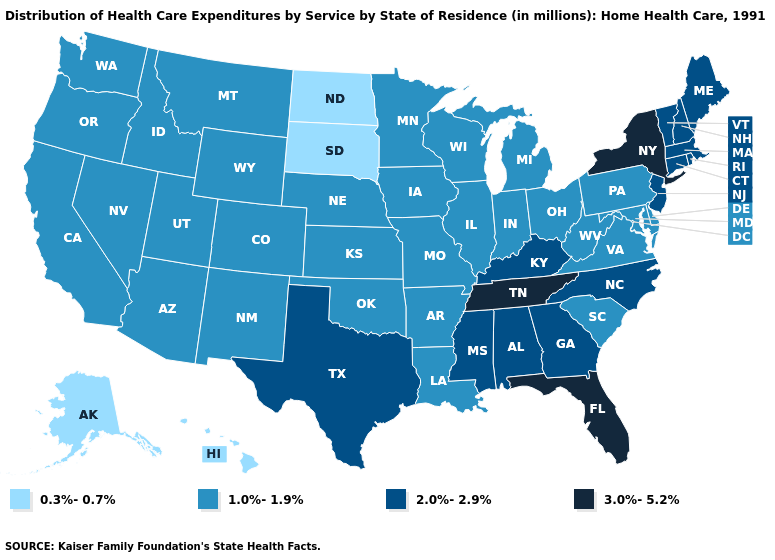What is the value of Michigan?
Answer briefly. 1.0%-1.9%. Name the states that have a value in the range 3.0%-5.2%?
Concise answer only. Florida, New York, Tennessee. Does Colorado have a lower value than North Carolina?
Write a very short answer. Yes. Does the map have missing data?
Quick response, please. No. Does Oregon have the lowest value in the USA?
Be succinct. No. What is the value of Arkansas?
Give a very brief answer. 1.0%-1.9%. What is the highest value in the USA?
Short answer required. 3.0%-5.2%. What is the value of Rhode Island?
Quick response, please. 2.0%-2.9%. Does Vermont have a lower value than North Carolina?
Concise answer only. No. What is the lowest value in states that border Kansas?
Keep it brief. 1.0%-1.9%. Does Nebraska have a lower value than Massachusetts?
Keep it brief. Yes. What is the value of Georgia?
Give a very brief answer. 2.0%-2.9%. What is the value of Wisconsin?
Concise answer only. 1.0%-1.9%. What is the value of Indiana?
Quick response, please. 1.0%-1.9%. Which states have the lowest value in the MidWest?
Answer briefly. North Dakota, South Dakota. 